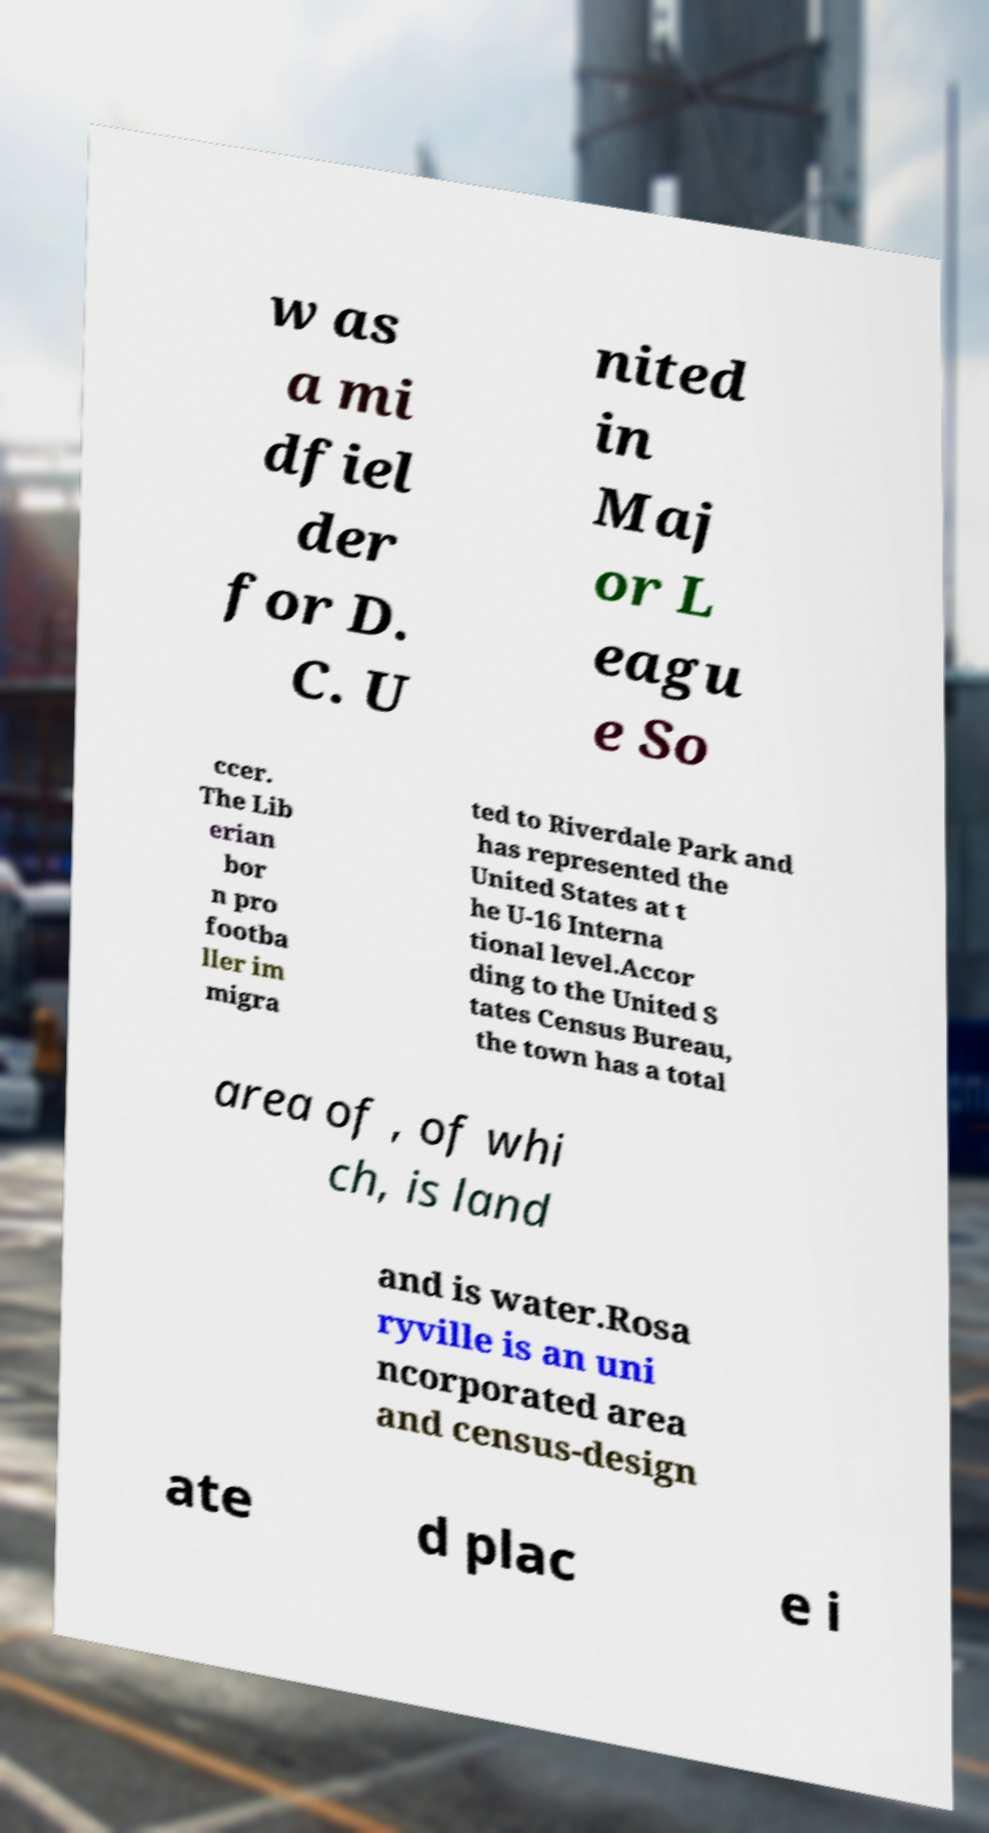What messages or text are displayed in this image? I need them in a readable, typed format. w as a mi dfiel der for D. C. U nited in Maj or L eagu e So ccer. The Lib erian bor n pro footba ller im migra ted to Riverdale Park and has represented the United States at t he U-16 Interna tional level.Accor ding to the United S tates Census Bureau, the town has a total area of , of whi ch, is land and is water.Rosa ryville is an uni ncorporated area and census-design ate d plac e i 